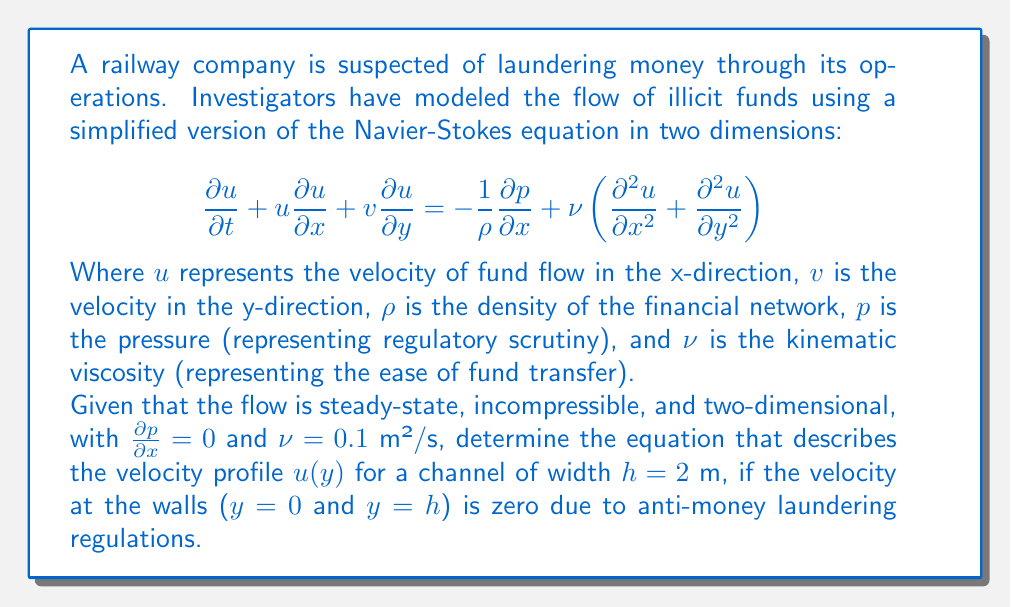Solve this math problem. To solve this problem, we need to follow these steps:

1) First, we simplify the Navier-Stokes equation based on the given conditions:
   - Steady-state: $\frac{\partial u}{\partial t} = 0$
   - Two-dimensional: $v = 0$
   - $\frac{\partial p}{\partial x} = 0$

2) The simplified equation becomes:

   $$0 = \nu\left(\frac{\partial^2 u}{\partial y^2}\right)$$

3) We can integrate this equation twice with respect to y:

   $$\frac{\partial u}{\partial y} = C_1$$
   $$u = C_1y + C_2$$

4) Now we apply the boundary conditions:
   - At y = 0, u = 0
   - At y = h, u = 0

5) Using the first condition (y = 0, u = 0):
   
   $$0 = C_2$$

6) Using the second condition (y = h, u = 0):
   
   $$0 = C_1h + C_2 = C_1h$$
   $$C_1 = -\frac{C_2}{h} = 0$$

7) However, this would lead to u = 0 everywhere, which is not a realistic solution. Instead, we can assume that there's a maximum velocity $U_m$ at the center of the channel (y = h/2).

8) With this new condition, we can write:

   $$u = A(y^2 - hy)$$

   Where A is a constant we need to determine.

9) The maximum velocity occurs at y = h/2:

   $$U_m = A(\frac{h^2}{4} - \frac{h^2}{2}) = -\frac{Ah^2}{4}$$
   $$A = -\frac{4U_m}{h^2}$$

10) Therefore, the final equation for the velocity profile is:

    $$u(y) = \frac{4U_m}{h^2}(hy - y^2)$$

This parabolic profile is characteristic of laminar flow between parallel plates, which in this case represents the flow of illicit funds within the constraints of the financial system.
Answer: $$u(y) = \frac{4U_m}{h^2}(hy - y^2)$$
Where $U_m$ is the maximum velocity at the center of the channel, h = 2 m is the width of the channel, and y is the distance from the wall. 